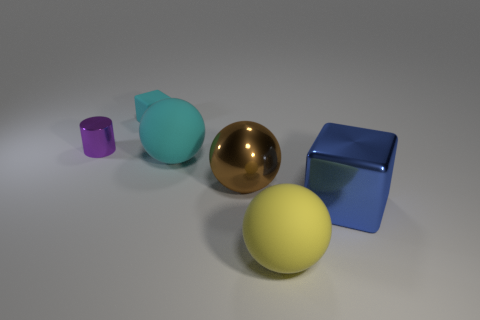Add 2 big brown rubber spheres. How many objects exist? 8 Subtract all blocks. How many objects are left? 4 Subtract all small cylinders. Subtract all small cyan things. How many objects are left? 4 Add 1 yellow things. How many yellow things are left? 2 Add 4 tiny green metallic objects. How many tiny green metallic objects exist? 4 Subtract 0 gray cylinders. How many objects are left? 6 